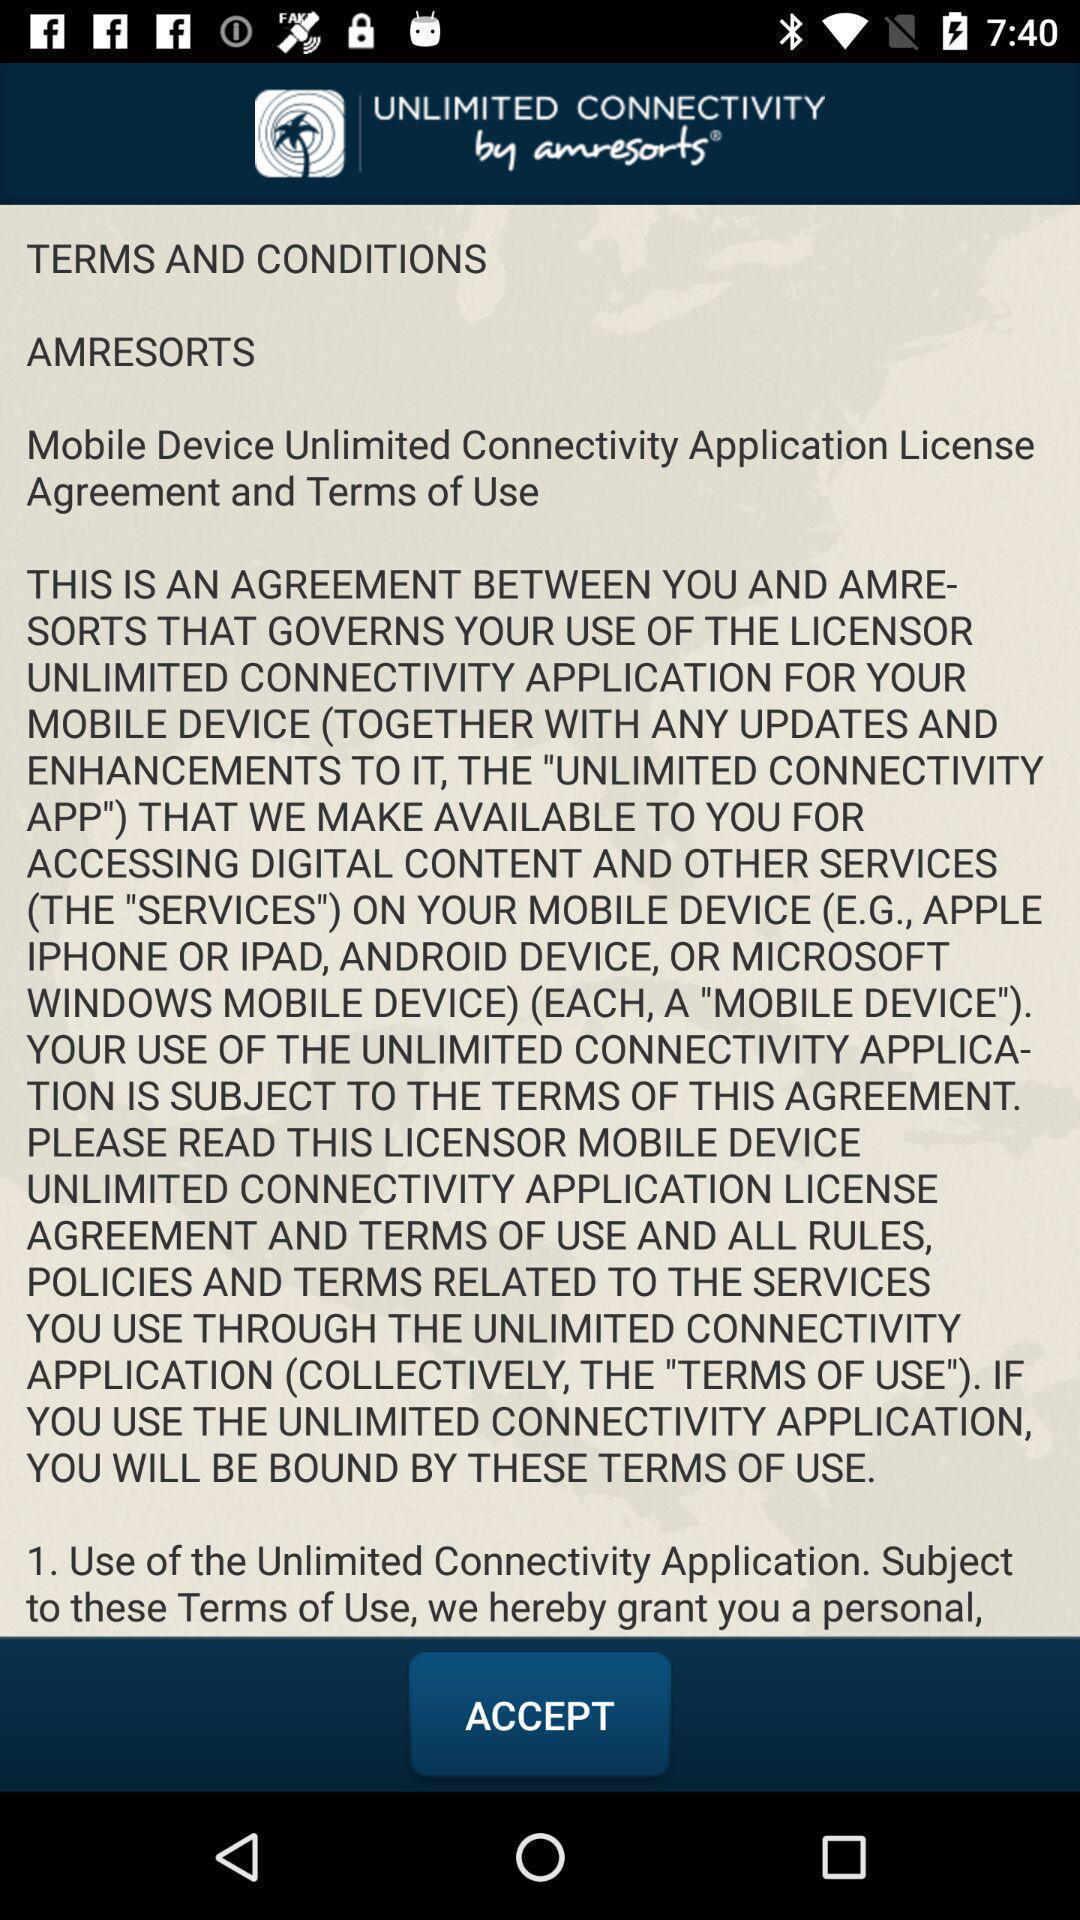Provide a detailed account of this screenshot. Screen displaying terms and conditions. 